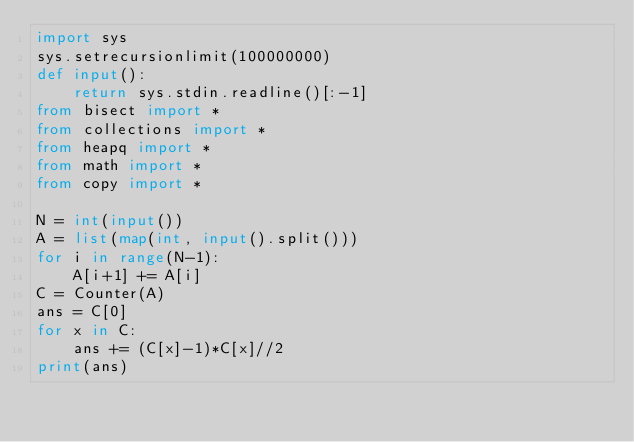Convert code to text. <code><loc_0><loc_0><loc_500><loc_500><_Python_>import sys
sys.setrecursionlimit(100000000)
def input():
    return sys.stdin.readline()[:-1]
from bisect import *
from collections import *
from heapq import *
from math import *
from copy import *

N = int(input())
A = list(map(int, input().split()))
for i in range(N-1):
    A[i+1] += A[i]
C = Counter(A)
ans = C[0]
for x in C:
    ans += (C[x]-1)*C[x]//2
print(ans)
</code> 